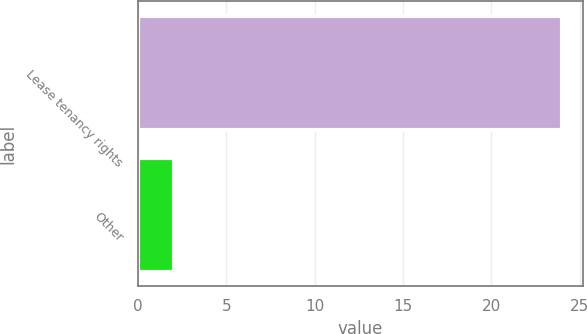Convert chart to OTSL. <chart><loc_0><loc_0><loc_500><loc_500><bar_chart><fcel>Lease tenancy rights<fcel>Other<nl><fcel>24<fcel>2<nl></chart> 